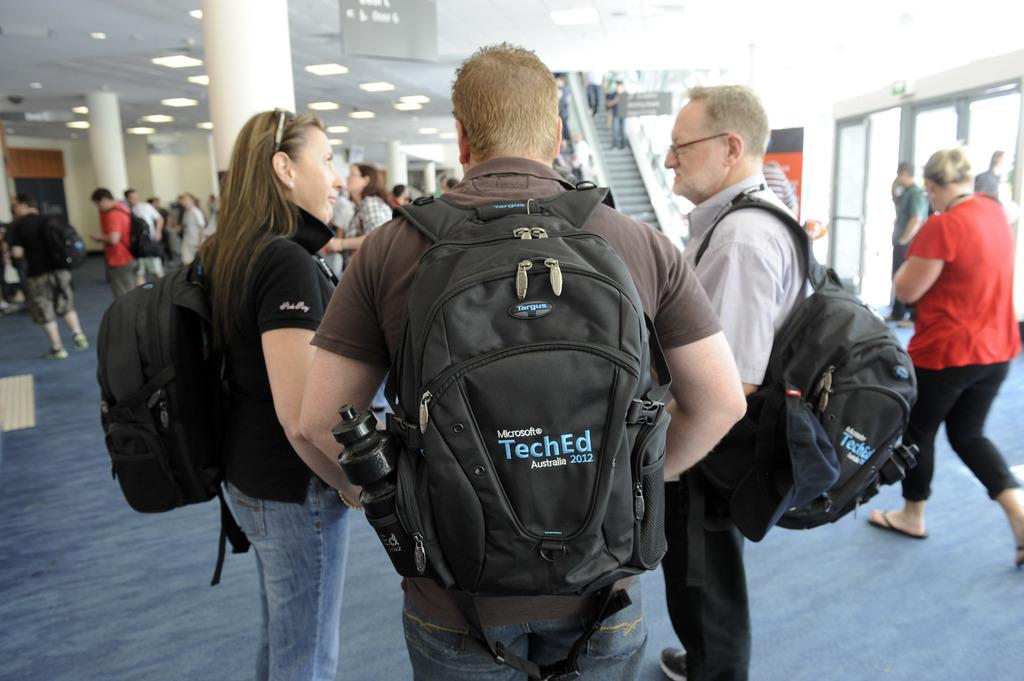Provide a one-sentence caption for the provided image. A man with the word "TechEd" on his backpack standing next to two other people. 